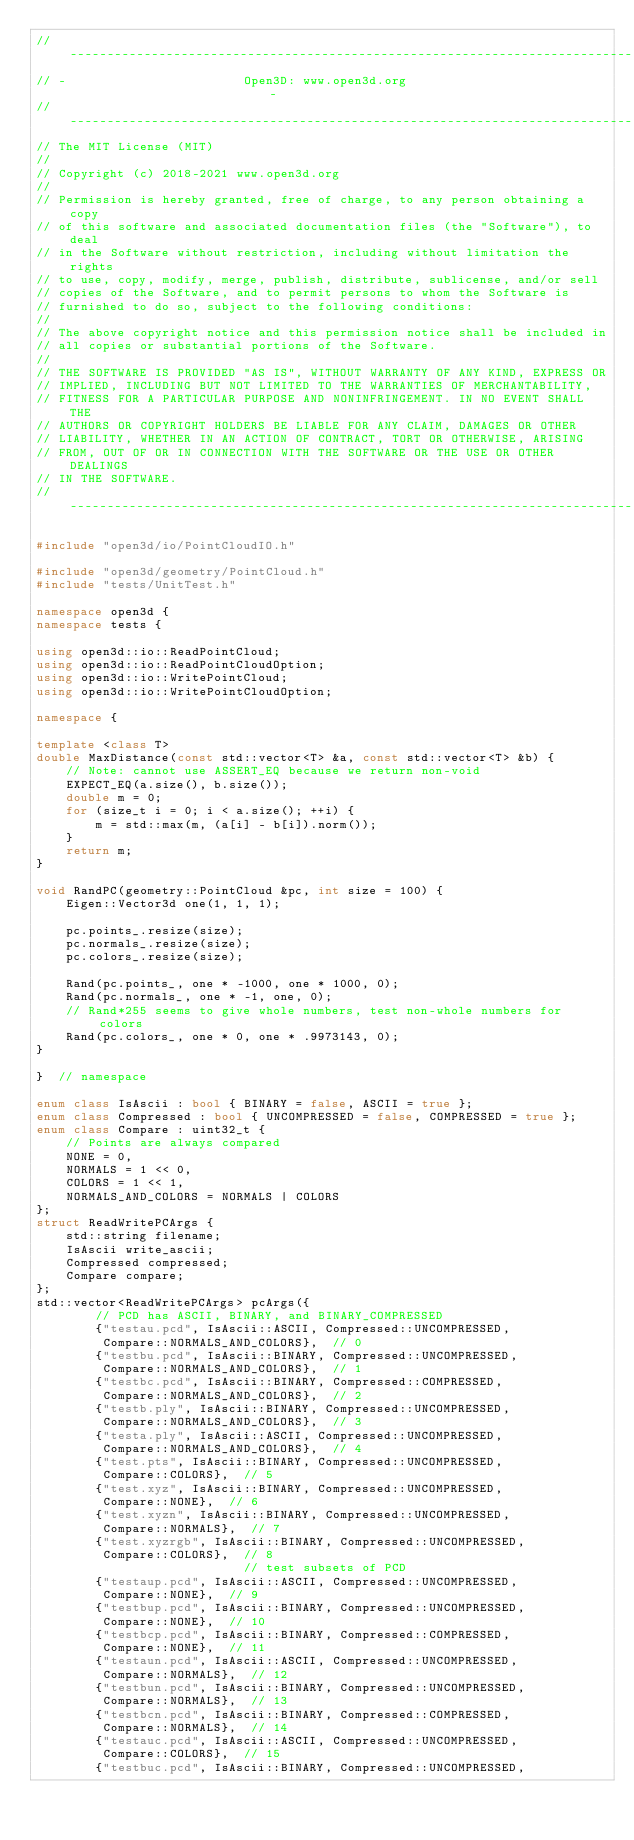Convert code to text. <code><loc_0><loc_0><loc_500><loc_500><_C++_>// ----------------------------------------------------------------------------
// -                        Open3D: www.open3d.org                            -
// ----------------------------------------------------------------------------
// The MIT License (MIT)
//
// Copyright (c) 2018-2021 www.open3d.org
//
// Permission is hereby granted, free of charge, to any person obtaining a copy
// of this software and associated documentation files (the "Software"), to deal
// in the Software without restriction, including without limitation the rights
// to use, copy, modify, merge, publish, distribute, sublicense, and/or sell
// copies of the Software, and to permit persons to whom the Software is
// furnished to do so, subject to the following conditions:
//
// The above copyright notice and this permission notice shall be included in
// all copies or substantial portions of the Software.
//
// THE SOFTWARE IS PROVIDED "AS IS", WITHOUT WARRANTY OF ANY KIND, EXPRESS OR
// IMPLIED, INCLUDING BUT NOT LIMITED TO THE WARRANTIES OF MERCHANTABILITY,
// FITNESS FOR A PARTICULAR PURPOSE AND NONINFRINGEMENT. IN NO EVENT SHALL THE
// AUTHORS OR COPYRIGHT HOLDERS BE LIABLE FOR ANY CLAIM, DAMAGES OR OTHER
// LIABILITY, WHETHER IN AN ACTION OF CONTRACT, TORT OR OTHERWISE, ARISING
// FROM, OUT OF OR IN CONNECTION WITH THE SOFTWARE OR THE USE OR OTHER DEALINGS
// IN THE SOFTWARE.
// ----------------------------------------------------------------------------

#include "open3d/io/PointCloudIO.h"

#include "open3d/geometry/PointCloud.h"
#include "tests/UnitTest.h"

namespace open3d {
namespace tests {

using open3d::io::ReadPointCloud;
using open3d::io::ReadPointCloudOption;
using open3d::io::WritePointCloud;
using open3d::io::WritePointCloudOption;

namespace {

template <class T>
double MaxDistance(const std::vector<T> &a, const std::vector<T> &b) {
    // Note: cannot use ASSERT_EQ because we return non-void
    EXPECT_EQ(a.size(), b.size());
    double m = 0;
    for (size_t i = 0; i < a.size(); ++i) {
        m = std::max(m, (a[i] - b[i]).norm());
    }
    return m;
}

void RandPC(geometry::PointCloud &pc, int size = 100) {
    Eigen::Vector3d one(1, 1, 1);

    pc.points_.resize(size);
    pc.normals_.resize(size);
    pc.colors_.resize(size);

    Rand(pc.points_, one * -1000, one * 1000, 0);
    Rand(pc.normals_, one * -1, one, 0);
    // Rand*255 seems to give whole numbers, test non-whole numbers for colors
    Rand(pc.colors_, one * 0, one * .9973143, 0);
}

}  // namespace

enum class IsAscii : bool { BINARY = false, ASCII = true };
enum class Compressed : bool { UNCOMPRESSED = false, COMPRESSED = true };
enum class Compare : uint32_t {
    // Points are always compared
    NONE = 0,
    NORMALS = 1 << 0,
    COLORS = 1 << 1,
    NORMALS_AND_COLORS = NORMALS | COLORS
};
struct ReadWritePCArgs {
    std::string filename;
    IsAscii write_ascii;
    Compressed compressed;
    Compare compare;
};
std::vector<ReadWritePCArgs> pcArgs({
        // PCD has ASCII, BINARY, and BINARY_COMPRESSED
        {"testau.pcd", IsAscii::ASCII, Compressed::UNCOMPRESSED,
         Compare::NORMALS_AND_COLORS},  // 0
        {"testbu.pcd", IsAscii::BINARY, Compressed::UNCOMPRESSED,
         Compare::NORMALS_AND_COLORS},  // 1
        {"testbc.pcd", IsAscii::BINARY, Compressed::COMPRESSED,
         Compare::NORMALS_AND_COLORS},  // 2
        {"testb.ply", IsAscii::BINARY, Compressed::UNCOMPRESSED,
         Compare::NORMALS_AND_COLORS},  // 3
        {"testa.ply", IsAscii::ASCII, Compressed::UNCOMPRESSED,
         Compare::NORMALS_AND_COLORS},  // 4
        {"test.pts", IsAscii::BINARY, Compressed::UNCOMPRESSED,
         Compare::COLORS},  // 5
        {"test.xyz", IsAscii::BINARY, Compressed::UNCOMPRESSED,
         Compare::NONE},  // 6
        {"test.xyzn", IsAscii::BINARY, Compressed::UNCOMPRESSED,
         Compare::NORMALS},  // 7
        {"test.xyzrgb", IsAscii::BINARY, Compressed::UNCOMPRESSED,
         Compare::COLORS},  // 8
                            // test subsets of PCD
        {"testaup.pcd", IsAscii::ASCII, Compressed::UNCOMPRESSED,
         Compare::NONE},  // 9
        {"testbup.pcd", IsAscii::BINARY, Compressed::UNCOMPRESSED,
         Compare::NONE},  // 10
        {"testbcp.pcd", IsAscii::BINARY, Compressed::COMPRESSED,
         Compare::NONE},  // 11
        {"testaun.pcd", IsAscii::ASCII, Compressed::UNCOMPRESSED,
         Compare::NORMALS},  // 12
        {"testbun.pcd", IsAscii::BINARY, Compressed::UNCOMPRESSED,
         Compare::NORMALS},  // 13
        {"testbcn.pcd", IsAscii::BINARY, Compressed::COMPRESSED,
         Compare::NORMALS},  // 14
        {"testauc.pcd", IsAscii::ASCII, Compressed::UNCOMPRESSED,
         Compare::COLORS},  // 15
        {"testbuc.pcd", IsAscii::BINARY, Compressed::UNCOMPRESSED,</code> 